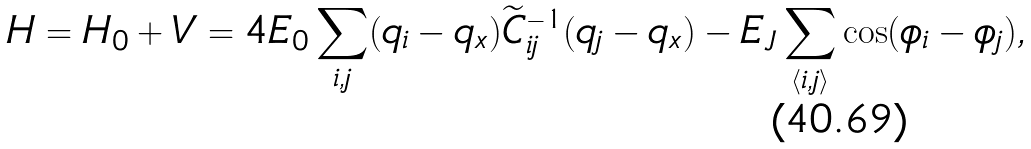<formula> <loc_0><loc_0><loc_500><loc_500>H = H _ { 0 } + V = 4 E _ { 0 } \sum _ { i , j } ( q _ { i } - q _ { x } ) { \widetilde { C } } _ { i j } ^ { - 1 } ( q _ { j } - q _ { x } ) - E _ { J } \sum _ { \langle i , j \rangle } \cos ( \phi _ { i } - \phi _ { j } ) ,</formula> 